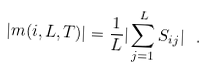Convert formula to latex. <formula><loc_0><loc_0><loc_500><loc_500>| m ( i , L , T ) | = \frac { 1 } { L } | \sum _ { j = 1 } ^ { L } S _ { i j } | \ \ .</formula> 